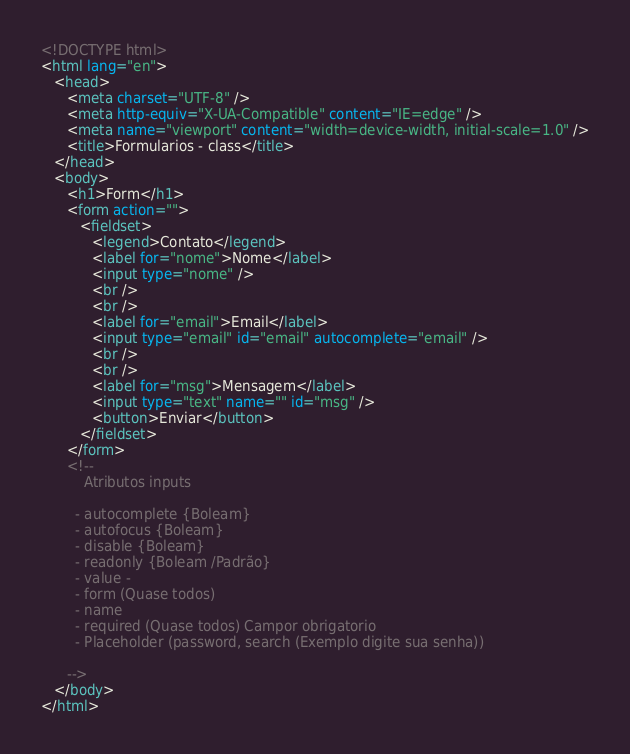<code> <loc_0><loc_0><loc_500><loc_500><_HTML_><!DOCTYPE html>
<html lang="en">
   <head>
      <meta charset="UTF-8" />
      <meta http-equiv="X-UA-Compatible" content="IE=edge" />
      <meta name="viewport" content="width=device-width, initial-scale=1.0" />
      <title>Formularios - class</title>
   </head>
   <body>
      <h1>Form</h1>
      <form action="">
         <fieldset>
            <legend>Contato</legend>
            <label for="nome">Nome</label>
            <input type="nome" />
            <br />
            <br />
            <label for="email">Email</label>
            <input type="email" id="email" autocomplete="email" />
            <br />
            <br />
            <label for="msg">Mensagem</label>
            <input type="text" name="" id="msg" />
            <button>Enviar</button>
         </fieldset>
      </form>
      <!--
          Atributos inputs

        - autocomplete {Boleam}
        - autofocus {Boleam}
        - disable {Boleam}
        - readonly {Boleam /Padrão}
        - value -
        - form (Quase todos)
        - name
        - required (Quase todos) Campor obrigatorio
        - Placeholder (password, search (Exemplo digite sua senha))

      -->
   </body>
</html>
</code> 